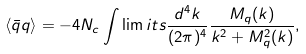<formula> <loc_0><loc_0><loc_500><loc_500>\langle \bar { q } q \rangle = - 4 N _ { c } \int \lim i t s \frac { d ^ { 4 } k } { ( 2 \pi ) ^ { 4 } } \frac { M _ { q } ( k ) } { k ^ { 2 } + M _ { q } ^ { 2 } ( k ) } ,</formula> 